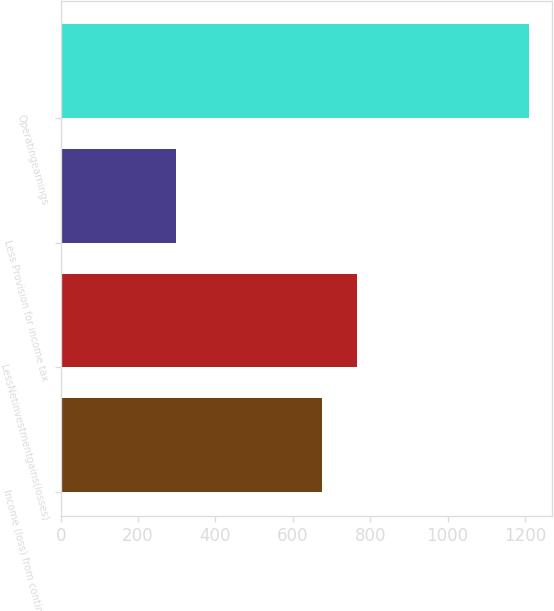Convert chart. <chart><loc_0><loc_0><loc_500><loc_500><bar_chart><fcel>Income (loss) from continuing<fcel>LessNetinvestmentgains(losses)<fcel>Less Provision for income tax<fcel>Operatingearnings<nl><fcel>675<fcel>766.2<fcel>298<fcel>1210<nl></chart> 